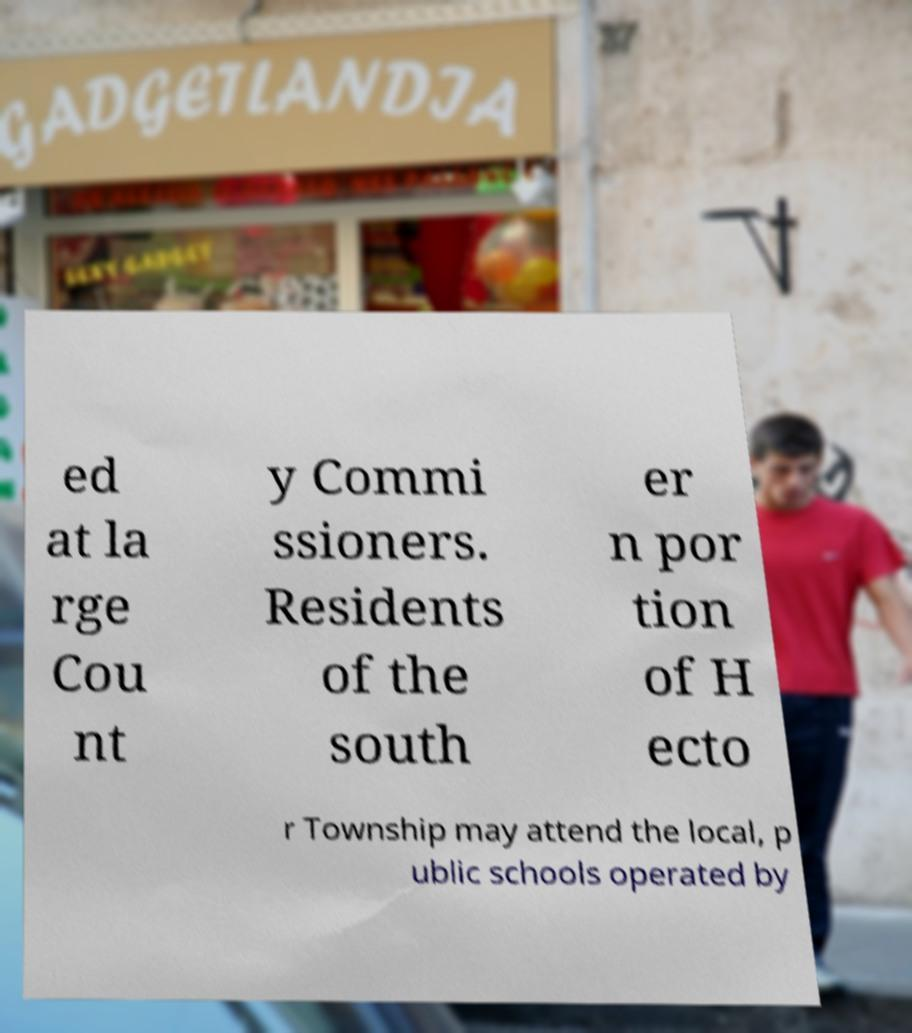Could you extract and type out the text from this image? ed at la rge Cou nt y Commi ssioners. Residents of the south er n por tion of H ecto r Township may attend the local, p ublic schools operated by 